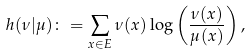<formula> <loc_0><loc_0><loc_500><loc_500>h ( \nu | \mu ) \colon = \sum _ { x \in E } \nu ( x ) \log \left ( \frac { \nu ( x ) } { \mu ( x ) } \right ) ,</formula> 